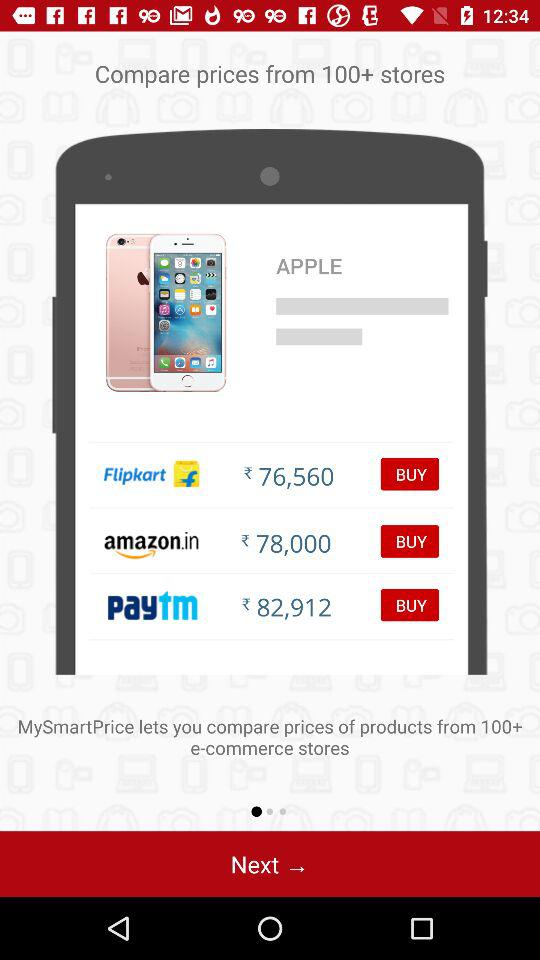Which store has the highest price for the iPhone 6s?
Answer the question using a single word or phrase. Paytm 